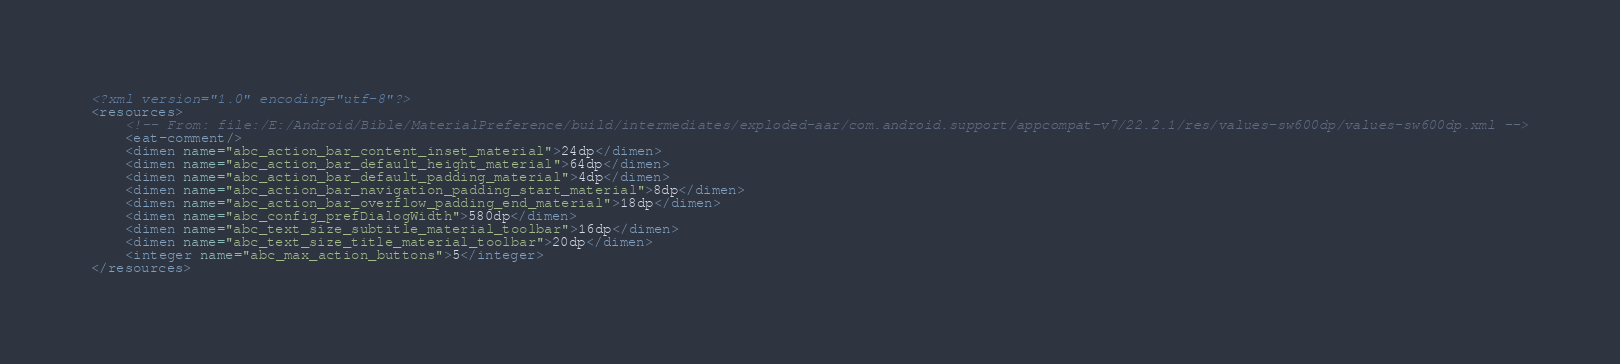<code> <loc_0><loc_0><loc_500><loc_500><_XML_><?xml version="1.0" encoding="utf-8"?>
<resources>
    <!-- From: file:/E:/Android/Bible/MaterialPreference/build/intermediates/exploded-aar/com.android.support/appcompat-v7/22.2.1/res/values-sw600dp/values-sw600dp.xml -->
    <eat-comment/>
    <dimen name="abc_action_bar_content_inset_material">24dp</dimen>
    <dimen name="abc_action_bar_default_height_material">64dp</dimen>
    <dimen name="abc_action_bar_default_padding_material">4dp</dimen>
    <dimen name="abc_action_bar_navigation_padding_start_material">8dp</dimen>
    <dimen name="abc_action_bar_overflow_padding_end_material">18dp</dimen>
    <dimen name="abc_config_prefDialogWidth">580dp</dimen>
    <dimen name="abc_text_size_subtitle_material_toolbar">16dp</dimen>
    <dimen name="abc_text_size_title_material_toolbar">20dp</dimen>
    <integer name="abc_max_action_buttons">5</integer>
</resources></code> 